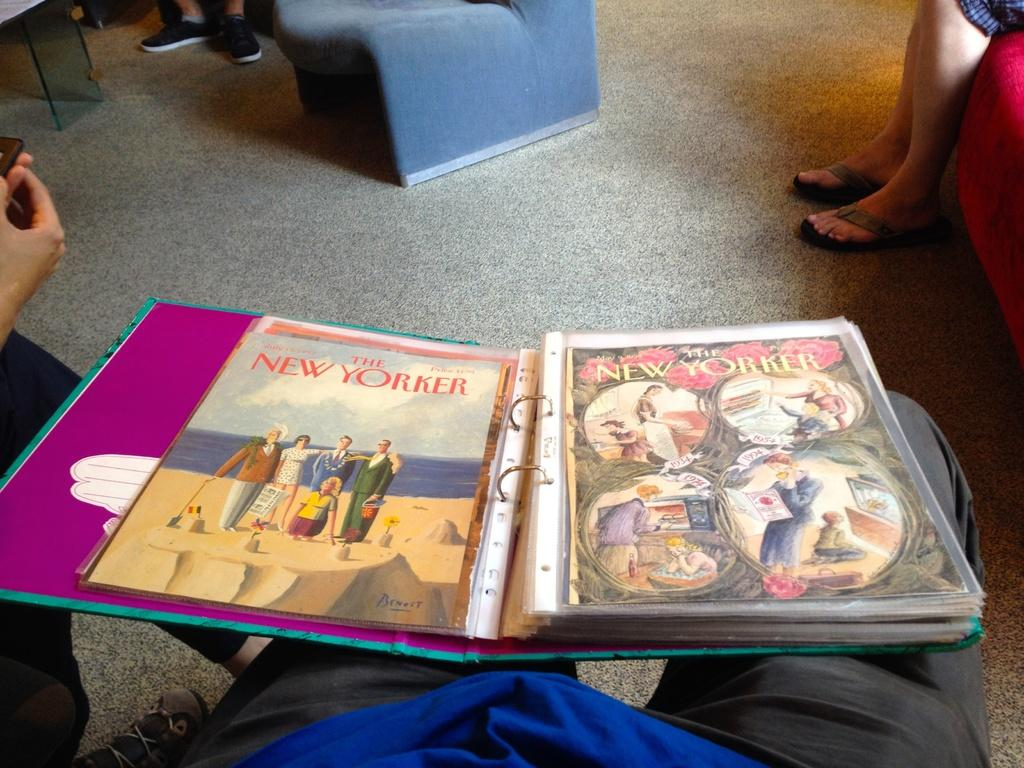<image>
Write a terse but informative summary of the picture. A notebook full of issues of The NEW YORKER magazine. 